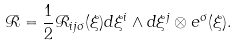<formula> <loc_0><loc_0><loc_500><loc_500>\mathcal { R } = \frac { 1 } { 2 } \mathcal { R } _ { i j \sigma } ( \xi ) d \xi ^ { i } \wedge d \xi ^ { j } \otimes e ^ { \sigma } ( \xi ) .</formula> 